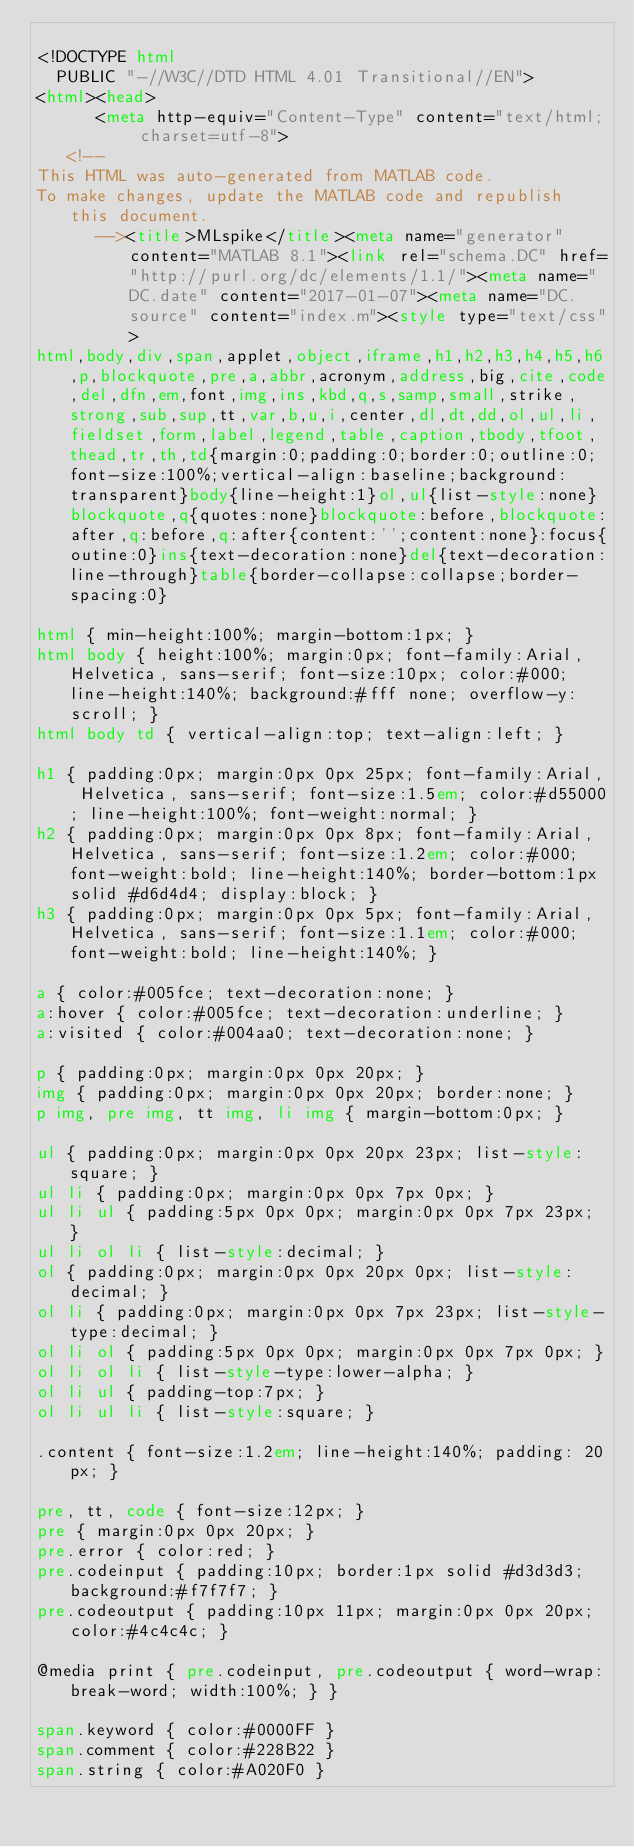<code> <loc_0><loc_0><loc_500><loc_500><_HTML_>
<!DOCTYPE html
  PUBLIC "-//W3C//DTD HTML 4.01 Transitional//EN">
<html><head>
      <meta http-equiv="Content-Type" content="text/html; charset=utf-8">
   <!--
This HTML was auto-generated from MATLAB code.
To make changes, update the MATLAB code and republish this document.
      --><title>MLspike</title><meta name="generator" content="MATLAB 8.1"><link rel="schema.DC" href="http://purl.org/dc/elements/1.1/"><meta name="DC.date" content="2017-01-07"><meta name="DC.source" content="index.m"><style type="text/css">
html,body,div,span,applet,object,iframe,h1,h2,h3,h4,h5,h6,p,blockquote,pre,a,abbr,acronym,address,big,cite,code,del,dfn,em,font,img,ins,kbd,q,s,samp,small,strike,strong,sub,sup,tt,var,b,u,i,center,dl,dt,dd,ol,ul,li,fieldset,form,label,legend,table,caption,tbody,tfoot,thead,tr,th,td{margin:0;padding:0;border:0;outline:0;font-size:100%;vertical-align:baseline;background:transparent}body{line-height:1}ol,ul{list-style:none}blockquote,q{quotes:none}blockquote:before,blockquote:after,q:before,q:after{content:'';content:none}:focus{outine:0}ins{text-decoration:none}del{text-decoration:line-through}table{border-collapse:collapse;border-spacing:0}

html { min-height:100%; margin-bottom:1px; }
html body { height:100%; margin:0px; font-family:Arial, Helvetica, sans-serif; font-size:10px; color:#000; line-height:140%; background:#fff none; overflow-y:scroll; }
html body td { vertical-align:top; text-align:left; }

h1 { padding:0px; margin:0px 0px 25px; font-family:Arial, Helvetica, sans-serif; font-size:1.5em; color:#d55000; line-height:100%; font-weight:normal; }
h2 { padding:0px; margin:0px 0px 8px; font-family:Arial, Helvetica, sans-serif; font-size:1.2em; color:#000; font-weight:bold; line-height:140%; border-bottom:1px solid #d6d4d4; display:block; }
h3 { padding:0px; margin:0px 0px 5px; font-family:Arial, Helvetica, sans-serif; font-size:1.1em; color:#000; font-weight:bold; line-height:140%; }

a { color:#005fce; text-decoration:none; }
a:hover { color:#005fce; text-decoration:underline; }
a:visited { color:#004aa0; text-decoration:none; }

p { padding:0px; margin:0px 0px 20px; }
img { padding:0px; margin:0px 0px 20px; border:none; }
p img, pre img, tt img, li img { margin-bottom:0px; } 

ul { padding:0px; margin:0px 0px 20px 23px; list-style:square; }
ul li { padding:0px; margin:0px 0px 7px 0px; }
ul li ul { padding:5px 0px 0px; margin:0px 0px 7px 23px; }
ul li ol li { list-style:decimal; }
ol { padding:0px; margin:0px 0px 20px 0px; list-style:decimal; }
ol li { padding:0px; margin:0px 0px 7px 23px; list-style-type:decimal; }
ol li ol { padding:5px 0px 0px; margin:0px 0px 7px 0px; }
ol li ol li { list-style-type:lower-alpha; }
ol li ul { padding-top:7px; }
ol li ul li { list-style:square; }

.content { font-size:1.2em; line-height:140%; padding: 20px; }

pre, tt, code { font-size:12px; }
pre { margin:0px 0px 20px; }
pre.error { color:red; }
pre.codeinput { padding:10px; border:1px solid #d3d3d3; background:#f7f7f7; }
pre.codeoutput { padding:10px 11px; margin:0px 0px 20px; color:#4c4c4c; }

@media print { pre.codeinput, pre.codeoutput { word-wrap:break-word; width:100%; } }

span.keyword { color:#0000FF }
span.comment { color:#228B22 }
span.string { color:#A020F0 }</code> 